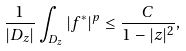Convert formula to latex. <formula><loc_0><loc_0><loc_500><loc_500>\frac { 1 } { | D _ { z } | } \int _ { D _ { z } } | f ^ { * } | ^ { p } \leq \frac { C } { 1 - | z | ^ { 2 } } ,</formula> 